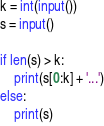Convert code to text. <code><loc_0><loc_0><loc_500><loc_500><_Python_>k = int(input())
s = input()

if len(s) > k:
    print(s[0:k] + '...')
else:
    print(s)</code> 